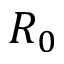<formula> <loc_0><loc_0><loc_500><loc_500>R _ { 0 }</formula> 